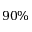Convert formula to latex. <formula><loc_0><loc_0><loc_500><loc_500>9 0 \%</formula> 